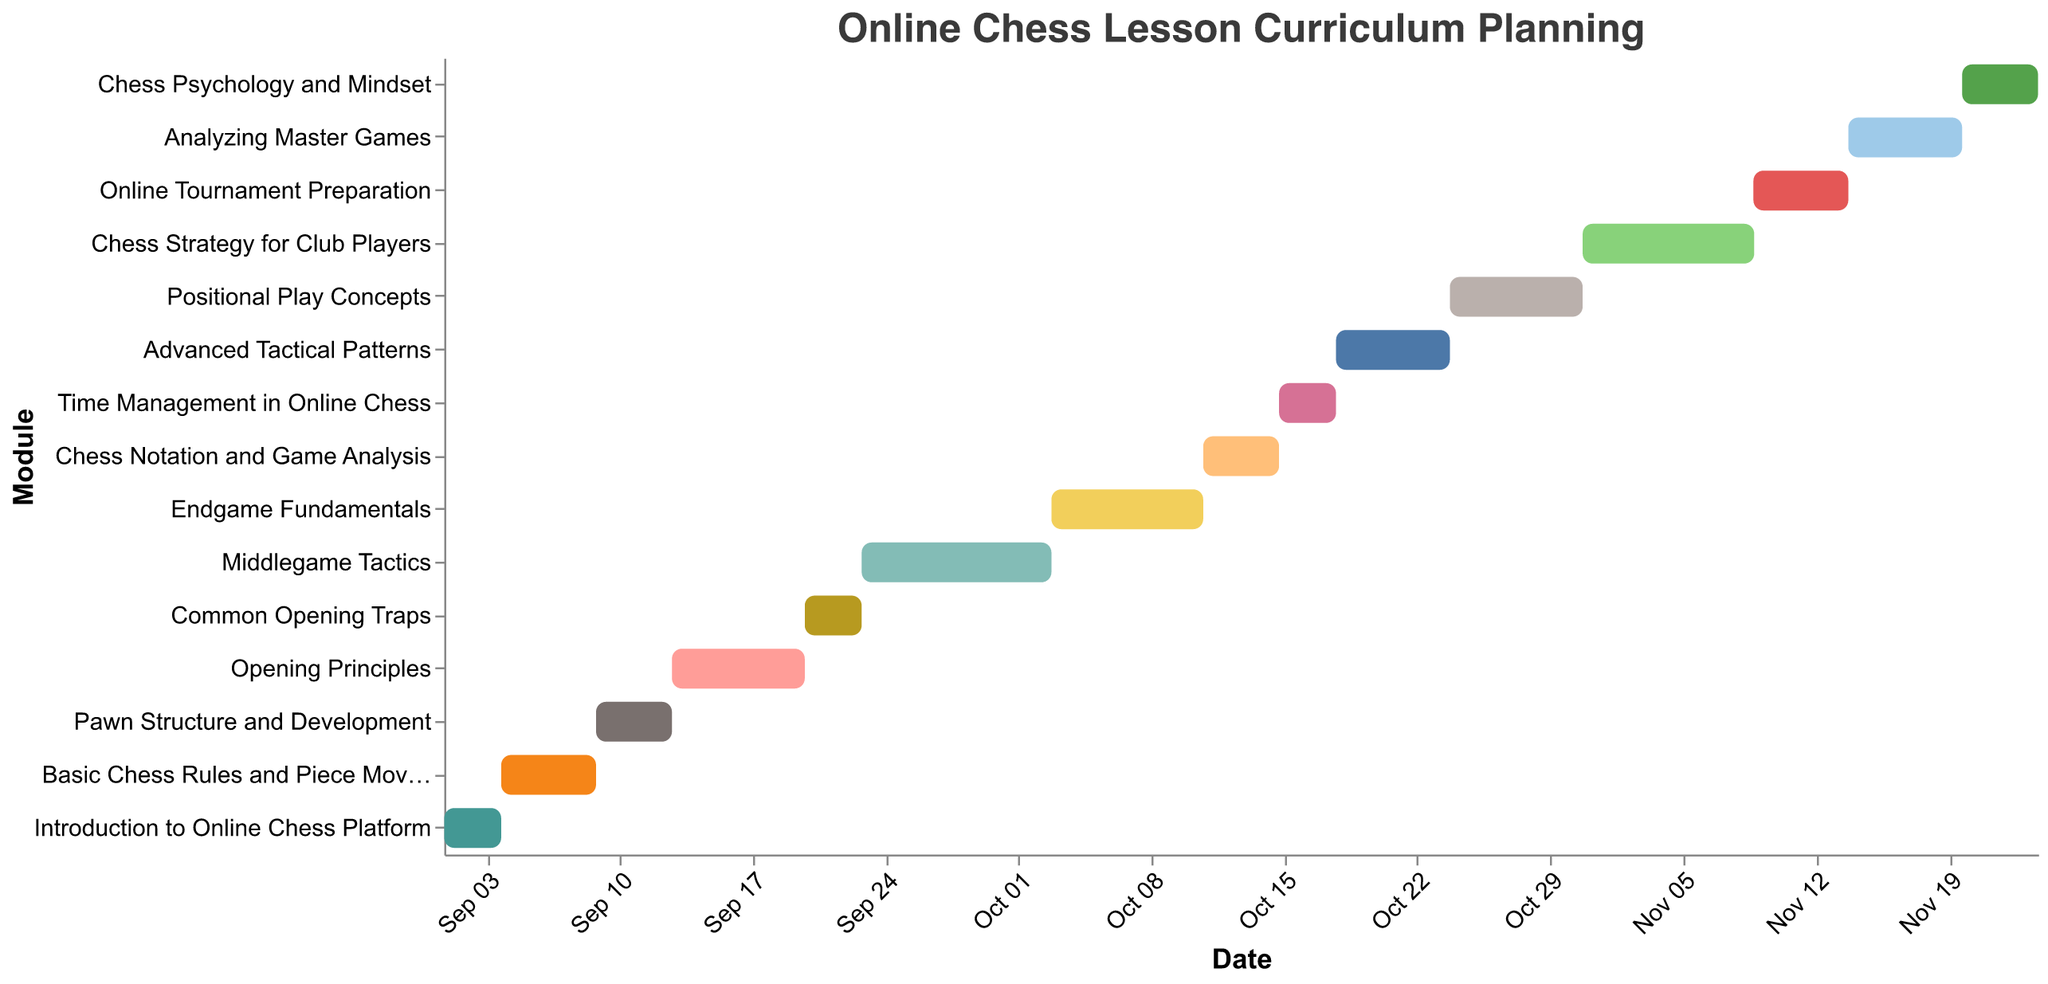What is the title of the Gantt Chart? The title is usually at the top of the chart and provides an overview of the figure's content.
Answer: Online Chess Lesson Curriculum Planning Which module lasts the longest? To find the longest module, look for the bar that spans the most days on the x-axis (horizontal). The "Middlegame Tactics" module spans from September 23 to October 3, which is 10 days.
Answer: Middlegame Tactics When does the "Advanced Tactical Patterns" module start and end? Locate the "Advanced Tactical Patterns" on the y-axis and identify its start date (October 18) and then add its duration (6 days) to determine the end date.
Answer: October 18 to October 24 How long is the "Opening Principles" module? Find the "Opening Principles" bar on the Gantt Chart and check its width along the x-axis between the start and end date, which represents its duration (7 days).
Answer: 7 days Which module starts immediately after the "Endgame Fundamentals"? Look for the end date of "Endgame Fundamentals" (October 11) and find the module that begins the next day or closest to that date, which is "Chess Notation and Game Analysis".
Answer: Chess Notation and Game Analysis What is the total duration of all modules starting in September? Identify all modules starting in September and sum their durations: Introduction to Online Chess Platform (3 days), Basic Chess Rules and Piece Movement (5 days), Pawn Structure and Development (4 days), Opening Principles (7 days), Common Opening Traps (3 days), and Middlegame Tactics (10 days). The total is 3 + 5 + 4 + 7 + 3 + 10 = 32 days.
Answer: 32 days Which module has the same duration as "Common Opening Traps"? Compare the duration of "Common Opening Traps" (3 days) with other modules to find any with the same duration. "Time Management in Online Chess" also lasts 3 days.
Answer: Time Management in Online Chess Which is the last module in the curriculum? Find the module farthest to the right on the x-axis. "Chess Psychology and Mindset" is the final module listed, ending on November 24.
Answer: Chess Psychology and Mindset What is the average duration of all the modules? Sum the durations of all modules and then divide by the number of modules. The total duration is 84 days, and there are 15 modules. The average is 84/15 = 5.6 days.
Answer: 5.6 days 